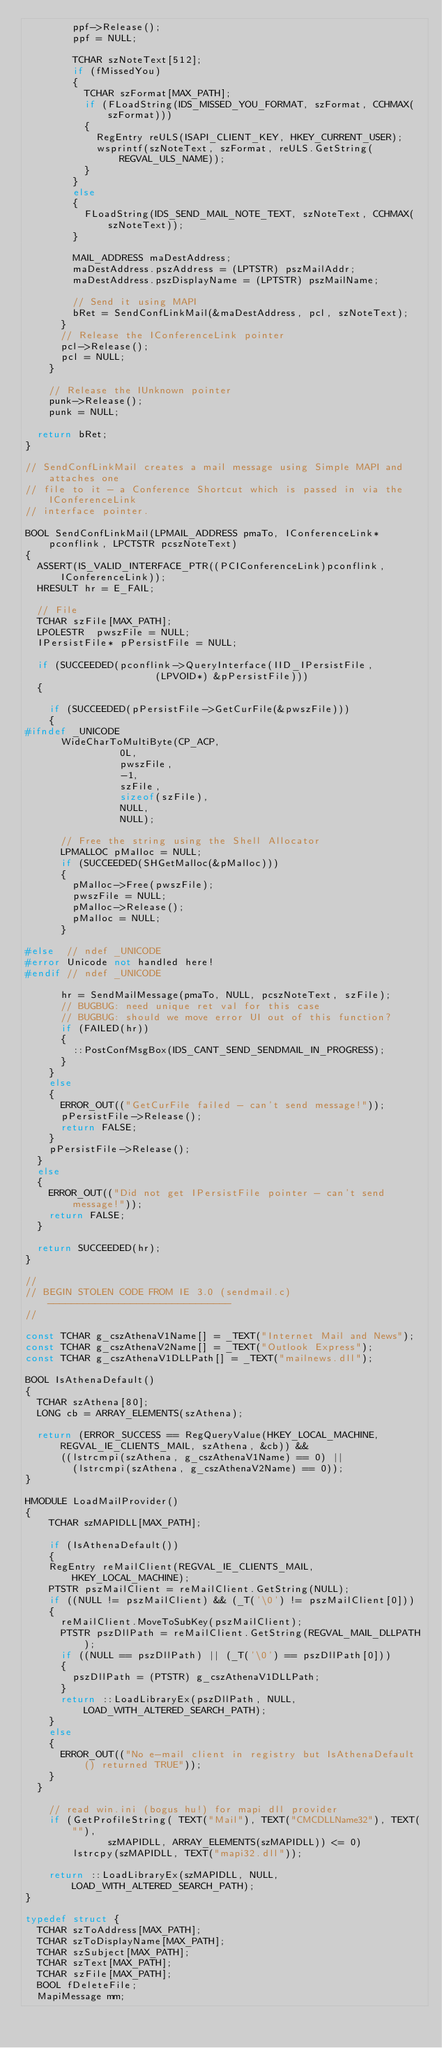<code> <loc_0><loc_0><loc_500><loc_500><_C++_>				ppf->Release();
				ppf = NULL;

				TCHAR szNoteText[512];
				if (fMissedYou)
				{
					TCHAR szFormat[MAX_PATH];
					if (FLoadString(IDS_MISSED_YOU_FORMAT, szFormat, CCHMAX(szFormat)))
					{
						RegEntry reULS(ISAPI_CLIENT_KEY, HKEY_CURRENT_USER);
						wsprintf(szNoteText, szFormat, reULS.GetString(REGVAL_ULS_NAME));
					}
				}
				else
				{
					FLoadString(IDS_SEND_MAIL_NOTE_TEXT, szNoteText, CCHMAX(szNoteText));
				}

				MAIL_ADDRESS maDestAddress;
				maDestAddress.pszAddress = (LPTSTR) pszMailAddr;
				maDestAddress.pszDisplayName = (LPTSTR) pszMailName;

				// Send it using MAPI
				bRet = SendConfLinkMail(&maDestAddress, pcl, szNoteText);
			}
			// Release the IConferenceLink pointer
			pcl->Release();
			pcl = NULL;
		}

		// Release the IUnknown pointer
		punk->Release();
		punk = NULL;

	return bRet;
}

// SendConfLinkMail creates a mail message using Simple MAPI and attaches one
// file to it - a Conference Shortcut which is passed in via the IConferenceLink
// interface pointer.

BOOL SendConfLinkMail(LPMAIL_ADDRESS pmaTo, IConferenceLink* pconflink, LPCTSTR pcszNoteText)
{
	ASSERT(IS_VALID_INTERFACE_PTR((PCIConferenceLink)pconflink, IConferenceLink));
	HRESULT hr = E_FAIL;

	// File
	TCHAR szFile[MAX_PATH];
	LPOLESTR	pwszFile = NULL;
	IPersistFile* pPersistFile = NULL;

	if (SUCCEEDED(pconflink->QueryInterface(IID_IPersistFile,
											(LPVOID*) &pPersistFile)))
	{
		
		if (SUCCEEDED(pPersistFile->GetCurFile(&pwszFile)))
		{
#ifndef _UNICODE
			WideCharToMultiByte(CP_ACP,
								0L,
								pwszFile,
								-1,
								szFile,
								sizeof(szFile),
								NULL,
								NULL);

			// Free the string using the Shell Allocator
			LPMALLOC pMalloc = NULL;
			if (SUCCEEDED(SHGetMalloc(&pMalloc)))
			{
				pMalloc->Free(pwszFile);
				pwszFile = NULL;
				pMalloc->Release();
				pMalloc = NULL;
			}

#else  // ndef _UNICODE
#error Unicode not handled here!
#endif // ndef _UNICODE

			hr = SendMailMessage(pmaTo, NULL, pcszNoteText, szFile);
			// BUGBUG: need unique ret val for this case
			// BUGBUG: should we move error UI out of this function?
			if (FAILED(hr))
			{
				::PostConfMsgBox(IDS_CANT_SEND_SENDMAIL_IN_PROGRESS);
			}
		}
		else
		{
			ERROR_OUT(("GetCurFile failed - can't send message!"));
			pPersistFile->Release();
			return FALSE;
		}
		pPersistFile->Release();
	}
	else
	{
		ERROR_OUT(("Did not get IPersistFile pointer - can't send message!"));
		return FALSE;
	}
	
	return SUCCEEDED(hr);
}

//
// BEGIN STOLEN CODE FROM IE 3.0 (sendmail.c) -------------------------------
//

const TCHAR g_cszAthenaV1Name[] = _TEXT("Internet Mail and News");
const TCHAR g_cszAthenaV2Name[] = _TEXT("Outlook Express");
const TCHAR g_cszAthenaV1DLLPath[] = _TEXT("mailnews.dll");

BOOL IsAthenaDefault()
{
	TCHAR szAthena[80];
	LONG cb = ARRAY_ELEMENTS(szAthena);

	return (ERROR_SUCCESS == RegQueryValue(HKEY_LOCAL_MACHINE, REGVAL_IE_CLIENTS_MAIL, szAthena, &cb)) &&
			((lstrcmpi(szAthena, g_cszAthenaV1Name) == 0) ||
				(lstrcmpi(szAthena, g_cszAthenaV2Name) == 0));
}

HMODULE LoadMailProvider()
{
    TCHAR szMAPIDLL[MAX_PATH];

    if (IsAthenaDefault())
    {
		RegEntry reMailClient(REGVAL_IE_CLIENTS_MAIL, HKEY_LOCAL_MACHINE);
		PTSTR pszMailClient = reMailClient.GetString(NULL);
		if ((NULL != pszMailClient) && (_T('\0') != pszMailClient[0]))
		{
			reMailClient.MoveToSubKey(pszMailClient);
			PTSTR pszDllPath = reMailClient.GetString(REGVAL_MAIL_DLLPATH);
			if ((NULL == pszDllPath) || (_T('\0') == pszDllPath[0]))
			{
				pszDllPath = (PTSTR) g_cszAthenaV1DLLPath;
			}
			return ::LoadLibraryEx(pszDllPath, NULL, LOAD_WITH_ALTERED_SEARCH_PATH);
		}
		else
		{
			ERROR_OUT(("No e-mail client in registry but IsAthenaDefault() returned TRUE"));
		}
	}

    // read win.ini (bogus hu!) for mapi dll provider
    if (GetProfileString(	TEXT("Mail"), TEXT("CMCDLLName32"), TEXT(""),
							szMAPIDLL, ARRAY_ELEMENTS(szMAPIDLL)) <= 0)
        lstrcpy(szMAPIDLL, TEXT("mapi32.dll"));

    return ::LoadLibraryEx(szMAPIDLL, NULL, LOAD_WITH_ALTERED_SEARCH_PATH);
}

typedef struct {
	TCHAR szToAddress[MAX_PATH];
	TCHAR szToDisplayName[MAX_PATH];
	TCHAR szSubject[MAX_PATH];
	TCHAR szText[MAX_PATH];
	TCHAR szFile[MAX_PATH];
	BOOL fDeleteFile;
	MapiMessage mm;</code> 